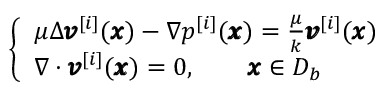<formula> <loc_0><loc_0><loc_500><loc_500>\left \{ \begin{array} { l l } { \mu \Delta { \pm b v } ^ { [ i ] } ( { \pm b x } ) - \nabla p ^ { [ i ] } ( { \pm b x } ) = \frac { \mu } { k } { \pm b v } ^ { [ i ] } ( { \pm b x } ) } \\ { \nabla \cdot { \pm b v } ^ { [ i ] } ( { \pm b x } ) = 0 , \quad { \pm b x } \in D _ { b } } \end{array}</formula> 